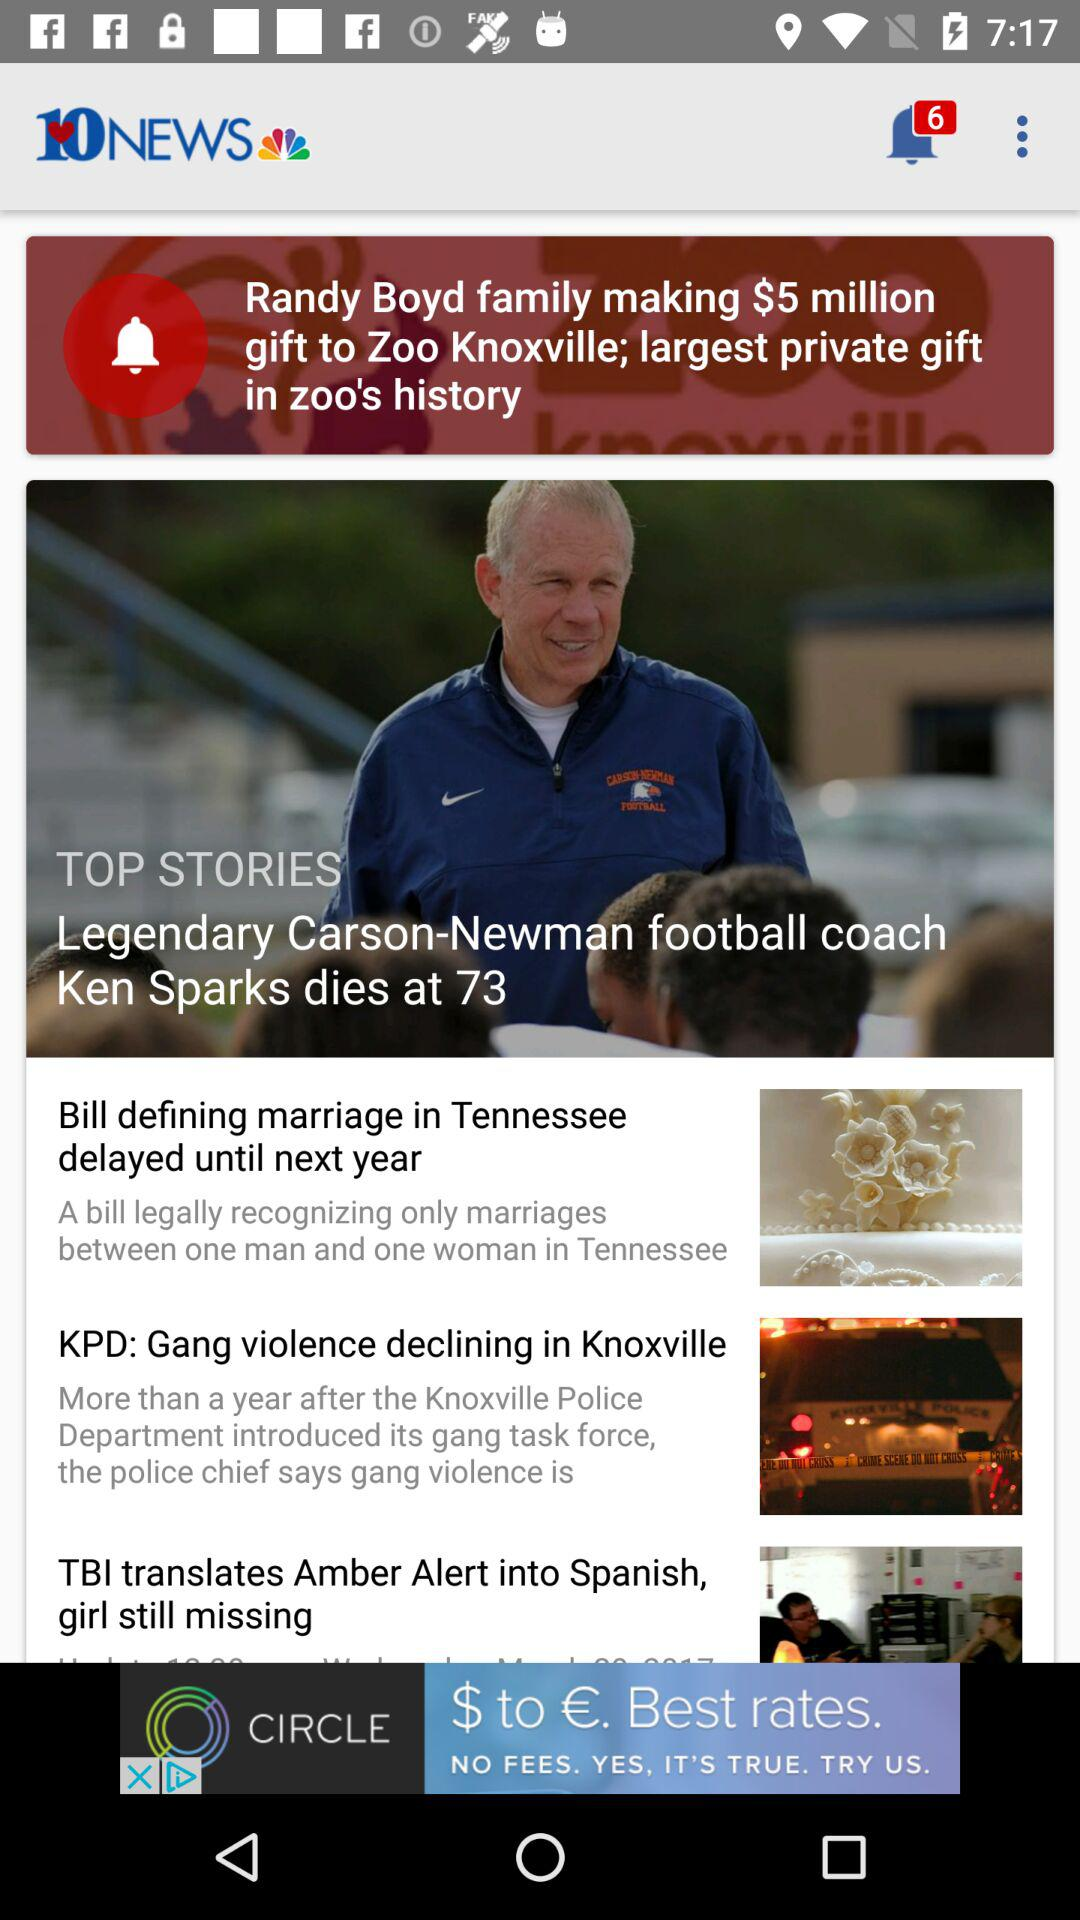How many stories are about sports?
Answer the question using a single word or phrase. 1 